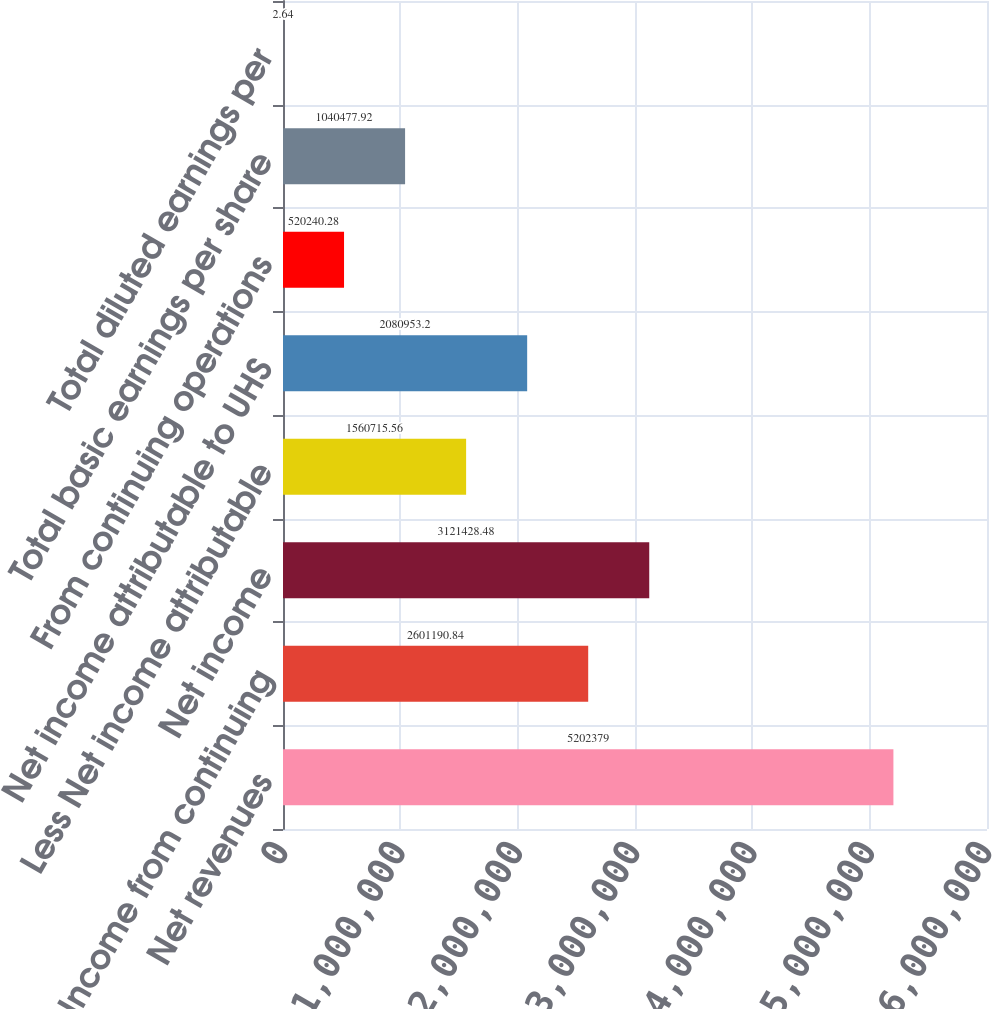Convert chart to OTSL. <chart><loc_0><loc_0><loc_500><loc_500><bar_chart><fcel>Net revenues<fcel>Income from continuing<fcel>Net income<fcel>Less Net income attributable<fcel>Net income attributable to UHS<fcel>From continuing operations<fcel>Total basic earnings per share<fcel>Total diluted earnings per<nl><fcel>5.20238e+06<fcel>2.60119e+06<fcel>3.12143e+06<fcel>1.56072e+06<fcel>2.08095e+06<fcel>520240<fcel>1.04048e+06<fcel>2.64<nl></chart> 